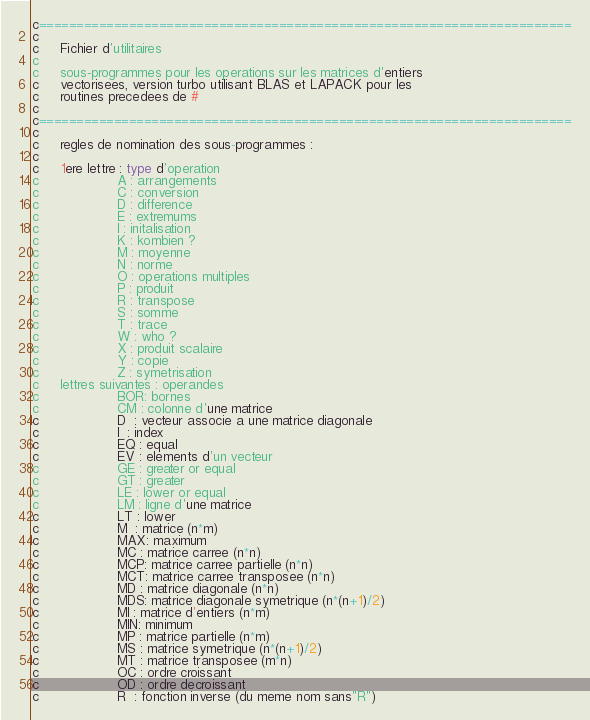<code> <loc_0><loc_0><loc_500><loc_500><_FORTRAN_>c=======================================================================
c
c     Fichier d'utilitaires                 
c
c     sous-programmes pour les operations sur les matrices d'entiers 
c     vectorisees, version turbo utilisant BLAS et LAPACK pour les 
c     routines precedees de # 
c
c=======================================================================
c
c     regles de nomination des sous-programmes :
c
c     1ere lettre : type d'operation
c                   A : arrangements
c                   C : conversion
c                   D : difference
c                   E : extremums
c                   I : initalisation
c                   K : kombien ?
c                   M : moyenne
c                   N : norme
c                   O : operations multiples
c                   P : produit
c                   R : transpose
c                   S : somme
c                   T : trace
c                   W : who ?
c                   X : produit scalaire
c                   Y : copie
c                   Z : symetrisation
c     lettres suivantes : operandes
c                   BOR: bornes
c                   CM : colonne d'une matrice
c                   D  : vecteur associe a une matrice diagonale
c                   I  : index
c                   EQ : equal
c                   EV : elements d'un vecteur
c                   GE : greater or equal
c                   GT : greater
c                   LE : lower or equal
c                   LM : ligne d'une matrice
c                   LT : lower
c                   M  : matrice (n*m)
c                   MAX: maximum
c                   MC : matrice carree (n*n)
c                   MCP: matrice carree partielle (n*n)
c                   MCT: matrice carree transposee (n*n)
c                   MD : matrice diagonale (n*n)
c                   MDS: matrice diagonale symetrique (n*(n+1)/2)
c                   MI : matrice d'entiers (n*m)
c                   MIN: minimum
c                   MP : matrice partielle (n*m)
c                   MS : matrice symetrique (n*(n+1)/2)
c                   MT : matrice transposee (m*n)
c                   OC : ordre croissant
c                   OD : ordre decroissant
c                   R  : fonction inverse (du meme nom sans"R")</code> 